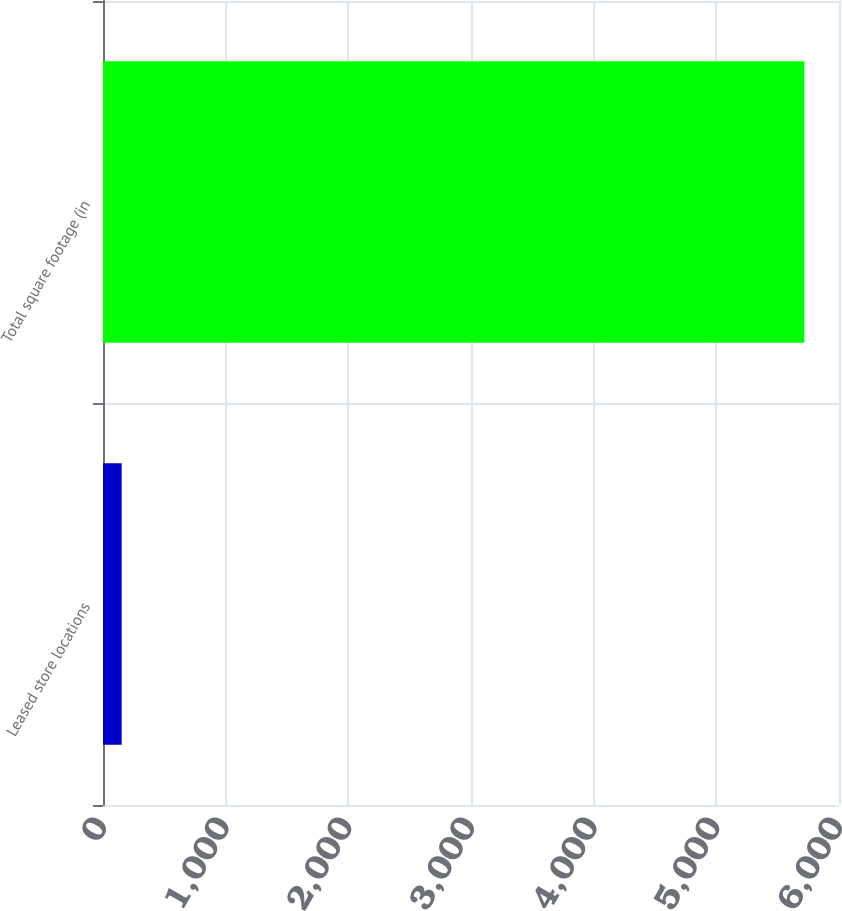Convert chart. <chart><loc_0><loc_0><loc_500><loc_500><bar_chart><fcel>Leased store locations<fcel>Total square footage (in<nl><fcel>152<fcel>5718<nl></chart> 